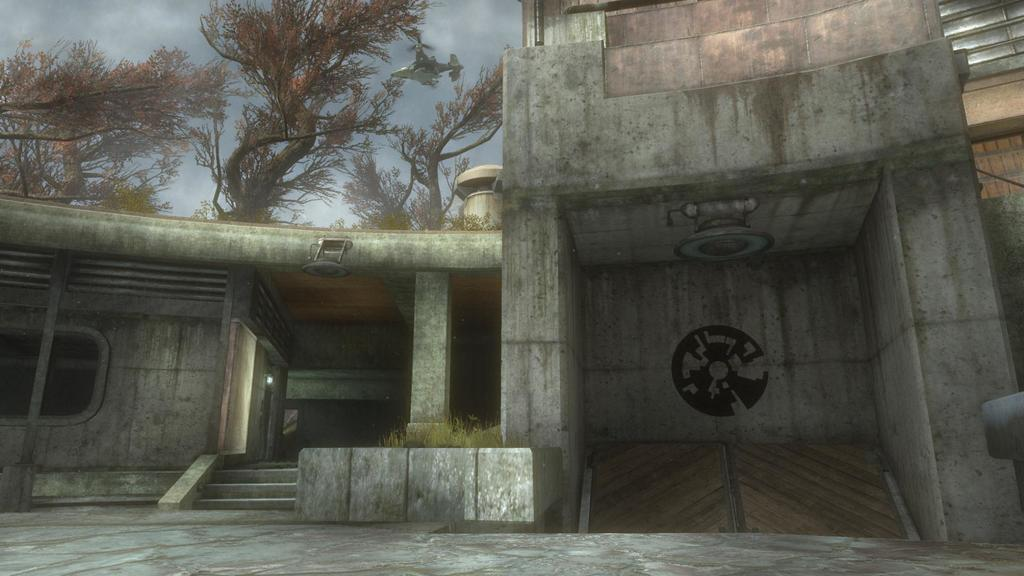What type of structures can be seen in the image? There are buildings in the image. What other elements are present in the image besides buildings? There are plants and a light visible in the image. What can be seen in the background of the image? There are trees and a plane in the background of the image. How does the downtown area look during the rainstorm in the image? There is no downtown area or rainstorm mentioned in the image; it only features buildings, plants, a light, trees, and a plane. 